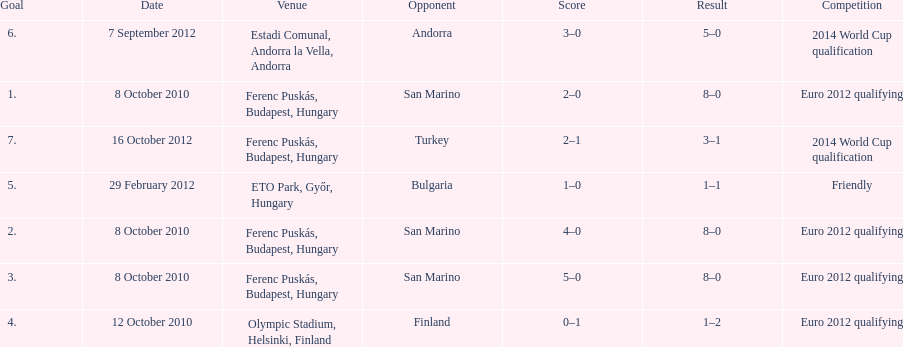In what year did ádám szalai make his next international goal after 2010? 2012. 